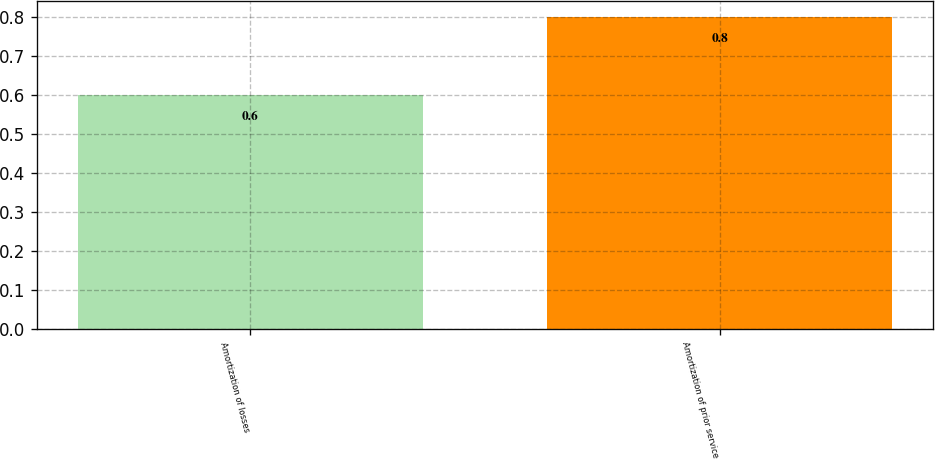<chart> <loc_0><loc_0><loc_500><loc_500><bar_chart><fcel>Amortization of losses<fcel>Amortization of prior service<nl><fcel>0.6<fcel>0.8<nl></chart> 